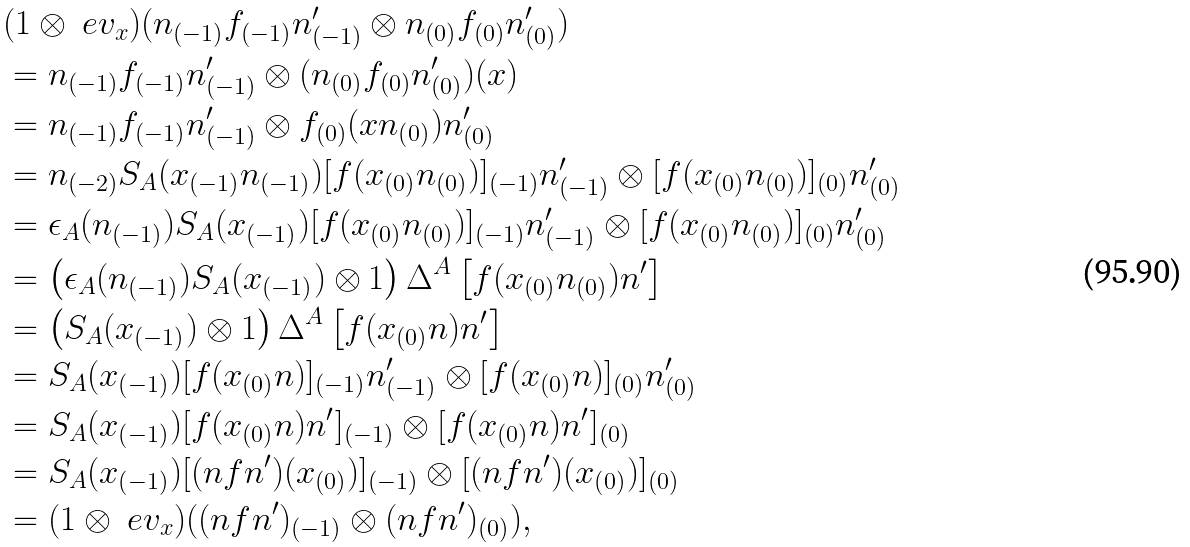<formula> <loc_0><loc_0><loc_500><loc_500>& ( 1 \otimes \ e v _ { x } ) ( n _ { ( - 1 ) } f _ { ( - 1 ) } n ^ { \prime } _ { ( - 1 ) } \otimes n _ { ( 0 ) } f _ { ( 0 ) } n ^ { \prime } _ { ( 0 ) } ) \\ & = n _ { ( - 1 ) } f _ { ( - 1 ) } n ^ { \prime } _ { ( - 1 ) } \otimes ( n _ { ( 0 ) } f _ { ( 0 ) } n ^ { \prime } _ { ( 0 ) } ) ( x ) \\ & = n _ { ( - 1 ) } f _ { ( - 1 ) } n ^ { \prime } _ { ( - 1 ) } \otimes f _ { ( 0 ) } ( x n _ { ( 0 ) } ) n ^ { \prime } _ { ( 0 ) } \\ & = n _ { ( - 2 ) } S _ { A } ( x _ { ( - 1 ) } n _ { ( - 1 ) } ) [ f ( x _ { ( 0 ) } n _ { ( 0 ) } ) ] _ { ( - 1 ) } n ^ { \prime } _ { ( - 1 ) } \otimes [ f ( x _ { ( 0 ) } n _ { ( 0 ) } ) ] _ { ( 0 ) } n ^ { \prime } _ { ( 0 ) } \\ & = \epsilon _ { A } ( n _ { ( - 1 ) } ) S _ { A } ( x _ { ( - 1 ) } ) [ f ( x _ { ( 0 ) } n _ { ( 0 ) } ) ] _ { ( - 1 ) } n ^ { \prime } _ { ( - 1 ) } \otimes [ f ( x _ { ( 0 ) } n _ { ( 0 ) } ) ] _ { ( 0 ) } n ^ { \prime } _ { ( 0 ) } \\ & = { \left ( \epsilon _ { A } ( n _ { ( - 1 ) } ) S _ { A } ( x _ { ( - 1 ) } ) \otimes 1 \right ) \Delta ^ { A } \left [ f ( x _ { ( 0 ) } n _ { ( 0 ) } ) n ^ { \prime } \right ] } \\ & = { \left ( S _ { A } ( x _ { ( - 1 ) } ) \otimes 1 \right ) \Delta ^ { A } \left [ f ( x _ { ( 0 ) } n ) n ^ { \prime } \right ] } \\ & = S _ { A } ( x _ { ( - 1 ) } ) [ f ( x _ { ( 0 ) } n ) ] _ { ( - 1 ) } n ^ { \prime } _ { ( - 1 ) } \otimes [ f ( x _ { ( 0 ) } n ) ] _ { ( 0 ) } n ^ { \prime } _ { ( 0 ) } \\ & = S _ { A } ( x _ { ( - 1 ) } ) [ f ( x _ { ( 0 ) } n ) n ^ { \prime } ] _ { ( - 1 ) } \otimes [ f ( x _ { ( 0 ) } n ) n ^ { \prime } ] _ { ( 0 ) } \\ & = S _ { A } ( x _ { ( - 1 ) } ) [ ( n f n ^ { \prime } ) ( x _ { ( 0 ) } ) ] _ { ( - 1 ) } \otimes [ ( n f n ^ { \prime } ) ( x _ { ( 0 ) } ) ] _ { ( 0 ) } \\ & = ( 1 \otimes \ e v _ { x } ) ( ( n f n ^ { \prime } ) _ { ( - 1 ) } \otimes ( n f n ^ { \prime } ) _ { ( 0 ) } ) ,</formula> 